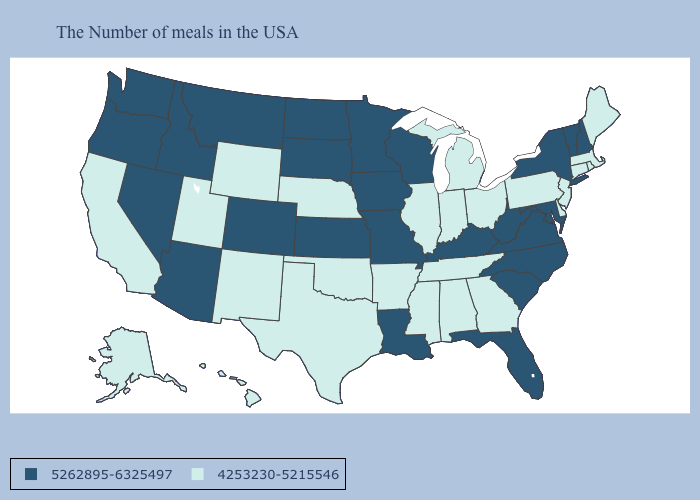Among the states that border Colorado , which have the lowest value?
Give a very brief answer. Nebraska, Oklahoma, Wyoming, New Mexico, Utah. Among the states that border Oregon , does Washington have the highest value?
Short answer required. Yes. Which states have the lowest value in the West?
Short answer required. Wyoming, New Mexico, Utah, California, Alaska, Hawaii. Does Missouri have the lowest value in the MidWest?
Keep it brief. No. What is the value of Mississippi?
Answer briefly. 4253230-5215546. Does New York have the highest value in the Northeast?
Answer briefly. Yes. Is the legend a continuous bar?
Answer briefly. No. Does Vermont have a higher value than Mississippi?
Answer briefly. Yes. How many symbols are there in the legend?
Give a very brief answer. 2. Name the states that have a value in the range 4253230-5215546?
Quick response, please. Maine, Massachusetts, Rhode Island, Connecticut, New Jersey, Delaware, Pennsylvania, Ohio, Georgia, Michigan, Indiana, Alabama, Tennessee, Illinois, Mississippi, Arkansas, Nebraska, Oklahoma, Texas, Wyoming, New Mexico, Utah, California, Alaska, Hawaii. Name the states that have a value in the range 4253230-5215546?
Be succinct. Maine, Massachusetts, Rhode Island, Connecticut, New Jersey, Delaware, Pennsylvania, Ohio, Georgia, Michigan, Indiana, Alabama, Tennessee, Illinois, Mississippi, Arkansas, Nebraska, Oklahoma, Texas, Wyoming, New Mexico, Utah, California, Alaska, Hawaii. What is the highest value in the West ?
Quick response, please. 5262895-6325497. Which states have the lowest value in the MidWest?
Quick response, please. Ohio, Michigan, Indiana, Illinois, Nebraska. Does New York have a higher value than Nevada?
Concise answer only. No. Does the first symbol in the legend represent the smallest category?
Concise answer only. No. 